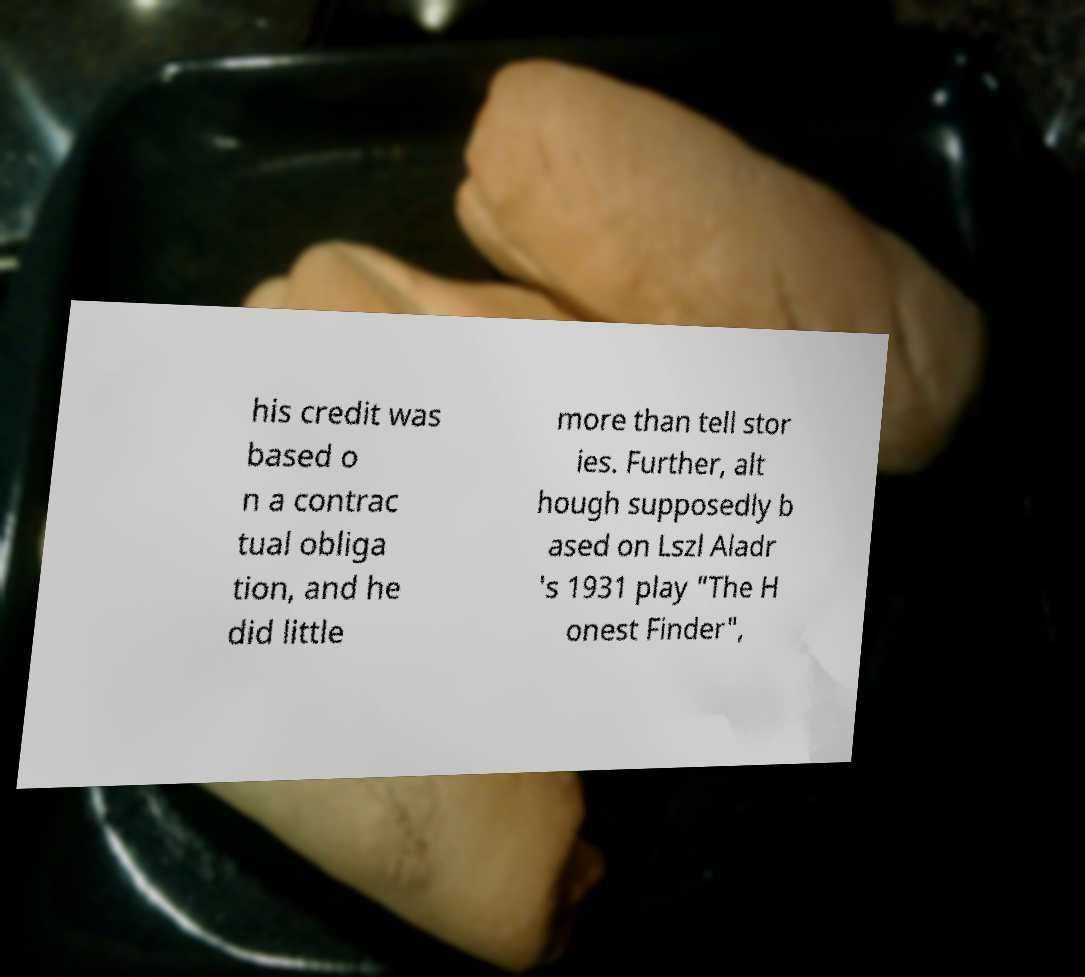Please read and relay the text visible in this image. What does it say? his credit was based o n a contrac tual obliga tion, and he did little more than tell stor ies. Further, alt hough supposedly b ased on Lszl Aladr 's 1931 play "The H onest Finder", 